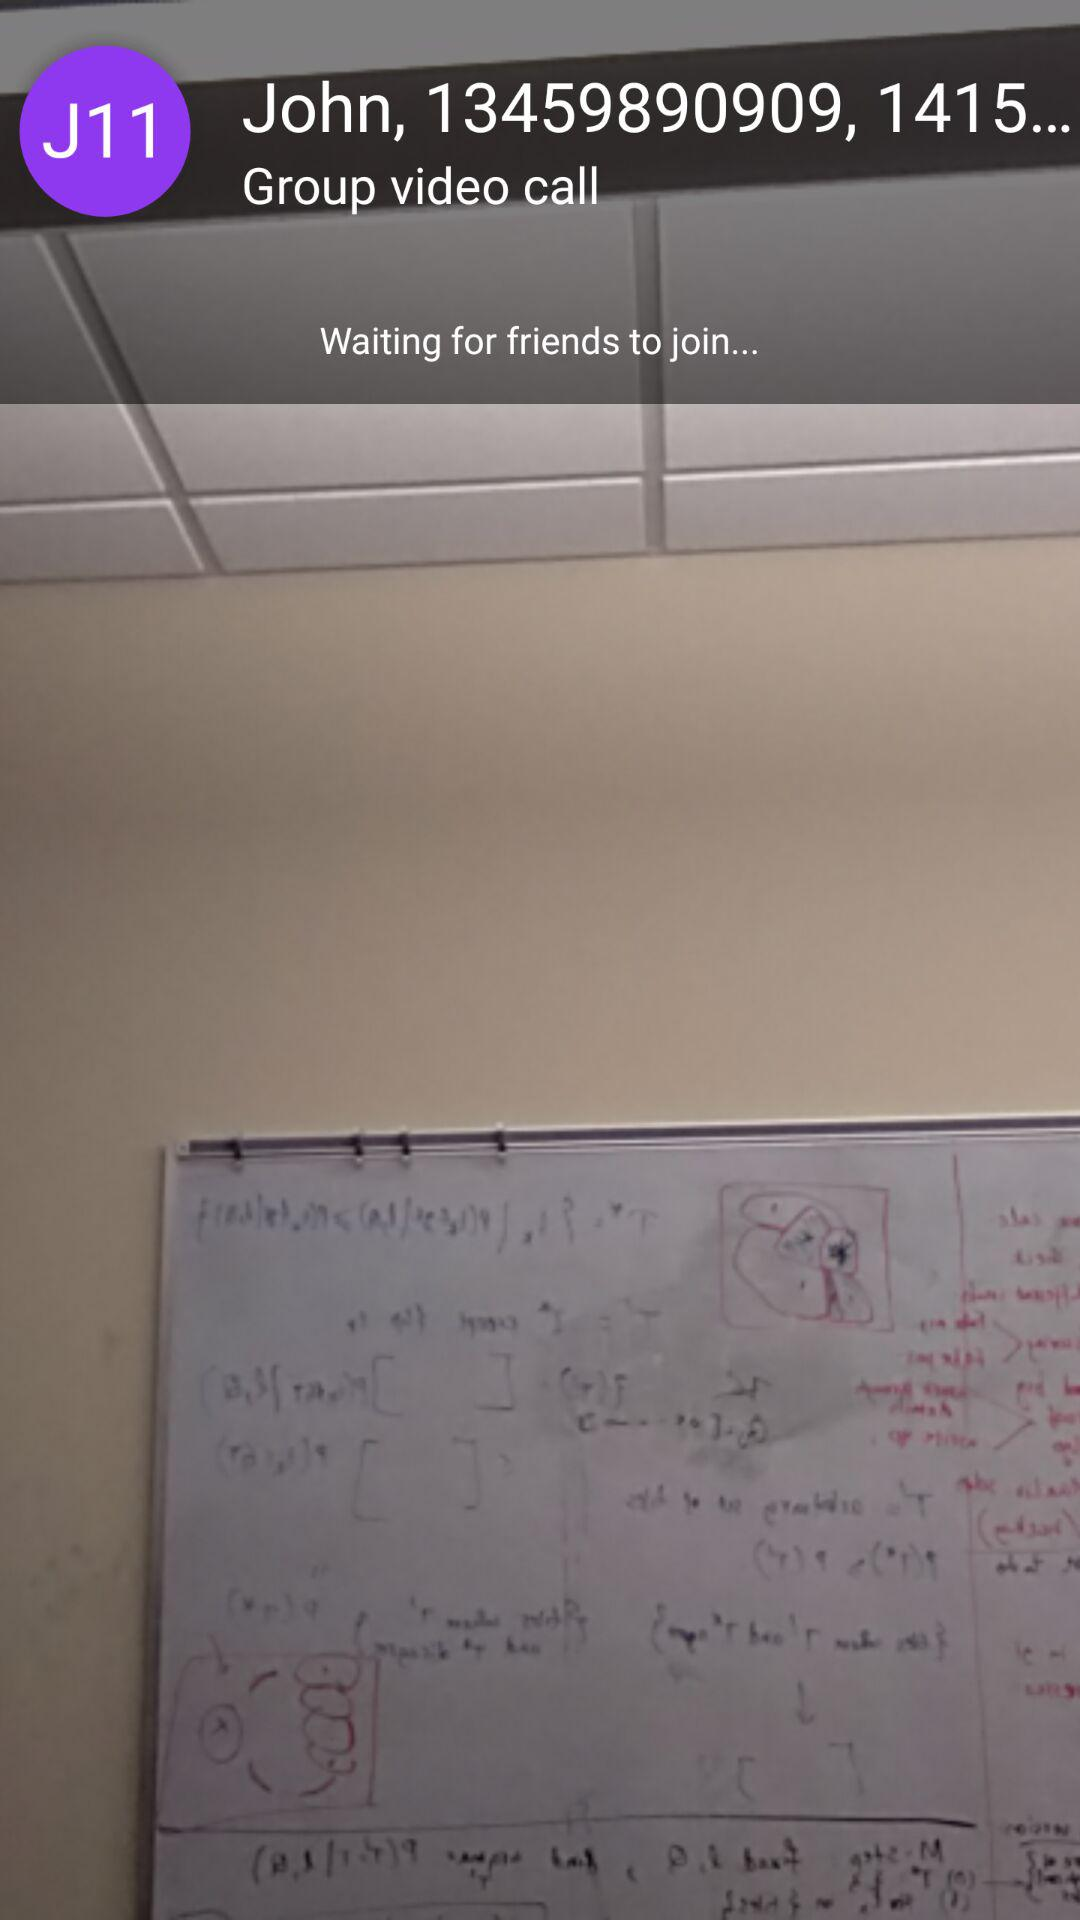What is the name of the user? The name of the user is John. 